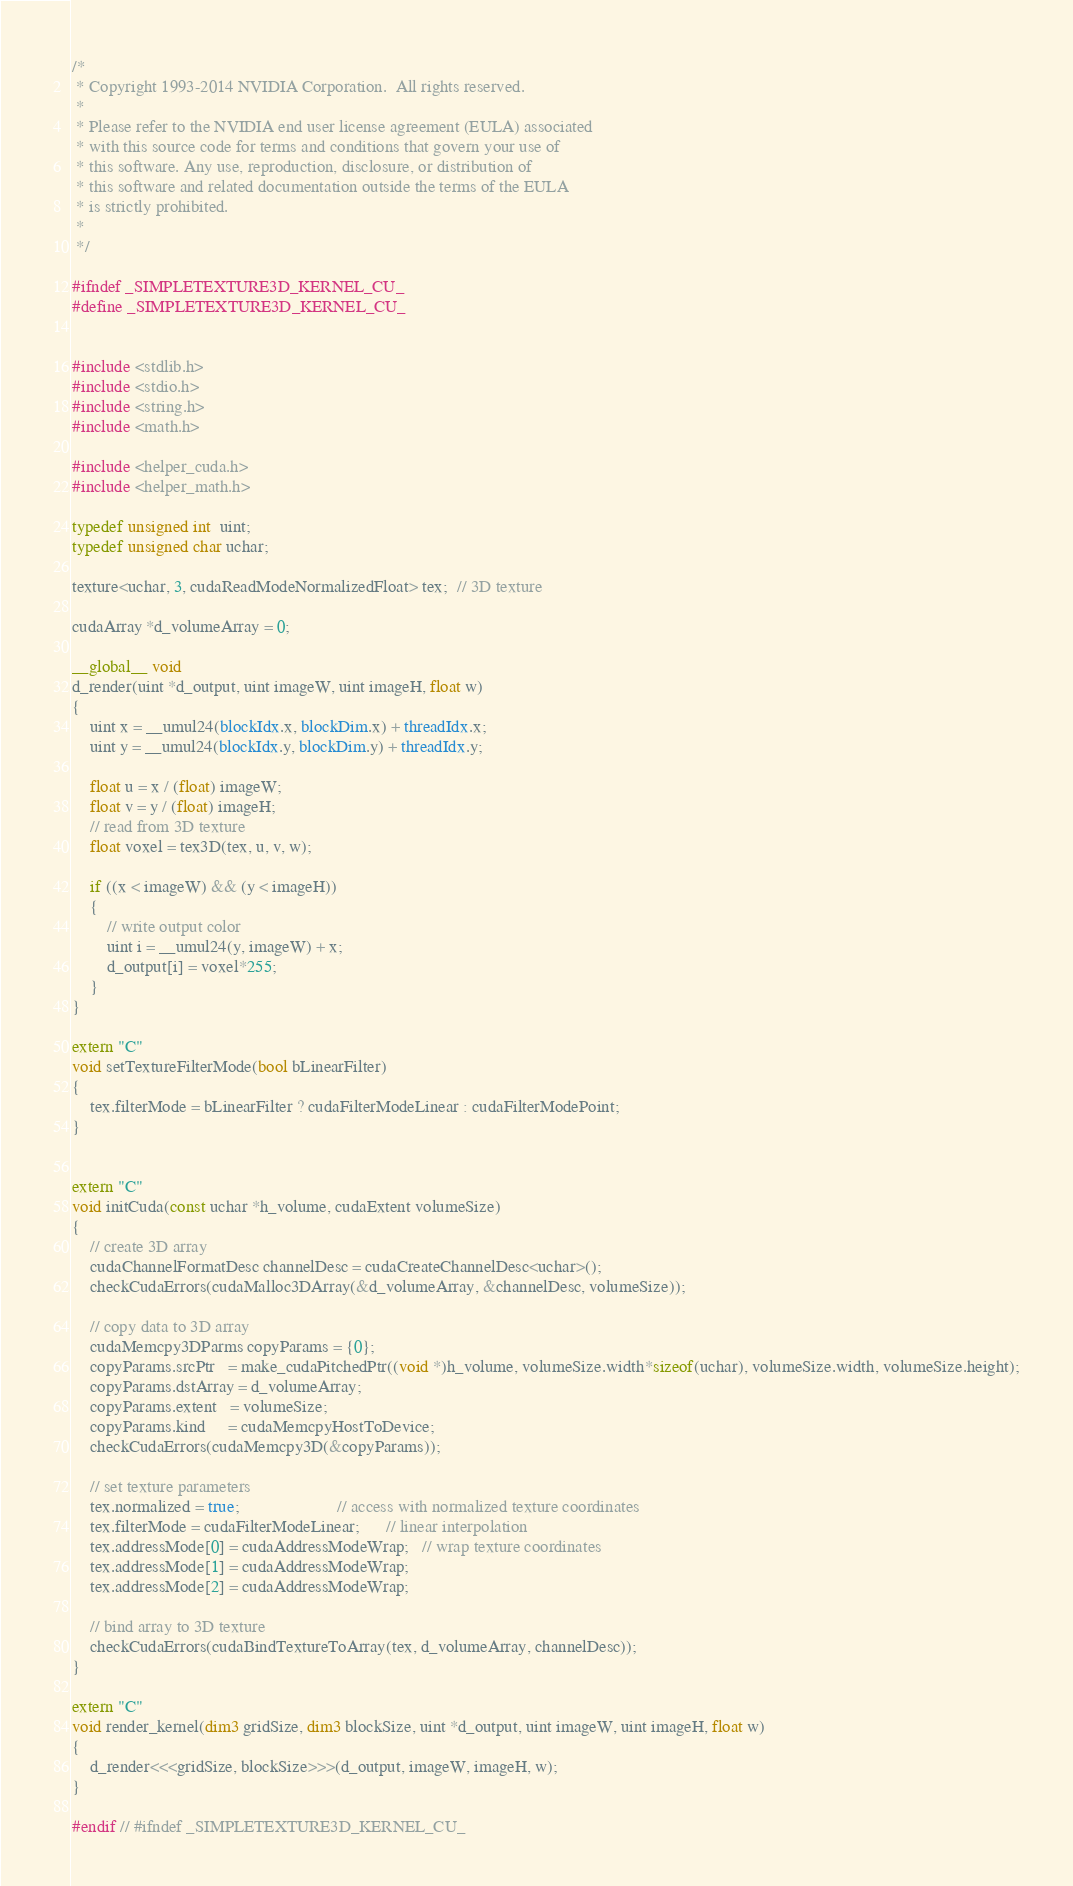<code> <loc_0><loc_0><loc_500><loc_500><_Cuda_>/*
 * Copyright 1993-2014 NVIDIA Corporation.  All rights reserved.
 *
 * Please refer to the NVIDIA end user license agreement (EULA) associated
 * with this source code for terms and conditions that govern your use of
 * this software. Any use, reproduction, disclosure, or distribution of
 * this software and related documentation outside the terms of the EULA
 * is strictly prohibited.
 *
 */

#ifndef _SIMPLETEXTURE3D_KERNEL_CU_
#define _SIMPLETEXTURE3D_KERNEL_CU_


#include <stdlib.h>
#include <stdio.h>
#include <string.h>
#include <math.h>

#include <helper_cuda.h>
#include <helper_math.h>

typedef unsigned int  uint;
typedef unsigned char uchar;

texture<uchar, 3, cudaReadModeNormalizedFloat> tex;  // 3D texture

cudaArray *d_volumeArray = 0;

__global__ void
d_render(uint *d_output, uint imageW, uint imageH, float w)
{
    uint x = __umul24(blockIdx.x, blockDim.x) + threadIdx.x;
    uint y = __umul24(blockIdx.y, blockDim.y) + threadIdx.y;

    float u = x / (float) imageW;
    float v = y / (float) imageH;
    // read from 3D texture
    float voxel = tex3D(tex, u, v, w);

    if ((x < imageW) && (y < imageH))
    {
        // write output color
        uint i = __umul24(y, imageW) + x;
        d_output[i] = voxel*255;
    }
}

extern "C"
void setTextureFilterMode(bool bLinearFilter)
{
    tex.filterMode = bLinearFilter ? cudaFilterModeLinear : cudaFilterModePoint;
}


extern "C"
void initCuda(const uchar *h_volume, cudaExtent volumeSize)
{
    // create 3D array
    cudaChannelFormatDesc channelDesc = cudaCreateChannelDesc<uchar>();
    checkCudaErrors(cudaMalloc3DArray(&d_volumeArray, &channelDesc, volumeSize));

    // copy data to 3D array
    cudaMemcpy3DParms copyParams = {0};
    copyParams.srcPtr   = make_cudaPitchedPtr((void *)h_volume, volumeSize.width*sizeof(uchar), volumeSize.width, volumeSize.height);
    copyParams.dstArray = d_volumeArray;
    copyParams.extent   = volumeSize;
    copyParams.kind     = cudaMemcpyHostToDevice;
    checkCudaErrors(cudaMemcpy3D(&copyParams));

    // set texture parameters
    tex.normalized = true;                      // access with normalized texture coordinates
    tex.filterMode = cudaFilterModeLinear;      // linear interpolation
    tex.addressMode[0] = cudaAddressModeWrap;   // wrap texture coordinates
    tex.addressMode[1] = cudaAddressModeWrap;
    tex.addressMode[2] = cudaAddressModeWrap;

    // bind array to 3D texture
    checkCudaErrors(cudaBindTextureToArray(tex, d_volumeArray, channelDesc));
}

extern "C"
void render_kernel(dim3 gridSize, dim3 blockSize, uint *d_output, uint imageW, uint imageH, float w)
{
    d_render<<<gridSize, blockSize>>>(d_output, imageW, imageH, w);
}

#endif // #ifndef _SIMPLETEXTURE3D_KERNEL_CU_
</code> 